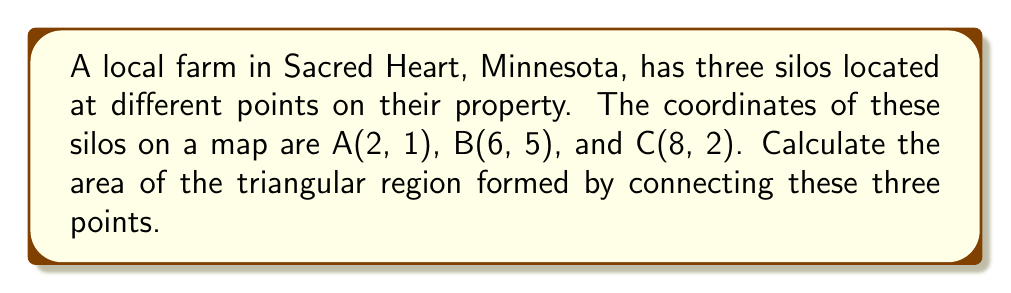Show me your answer to this math problem. To calculate the area of a triangle formed by three points on a coordinate plane, we can use the formula:

$$\text{Area} = \frac{1}{2}|x_1(y_2 - y_3) + x_2(y_3 - y_1) + x_3(y_1 - y_2)|$$

Where $(x_1, y_1)$, $(x_2, y_2)$, and $(x_3, y_3)$ are the coordinates of the three points.

Given:
- Point A: $(2, 1)$
- Point B: $(6, 5)$
- Point C: $(8, 2)$

Let's substitute these values into the formula:

$$\begin{align*}
\text{Area} &= \frac{1}{2}|2(5 - 2) + 6(2 - 1) + 8(1 - 5)| \\[6pt]
&= \frac{1}{2}|2(3) + 6(1) + 8(-4)| \\[6pt]
&= \frac{1}{2}|6 + 6 - 32| \\[6pt]
&= \frac{1}{2}|-20| \\[6pt]
&= \frac{1}{2}(20) \\[6pt]
&= 10
\end{align*}$$

Therefore, the area of the triangle formed by the three silos is 10 square units.

[asy]
unitsize(1cm);
defaultpen(fontsize(10pt));

pair A = (2,1);
pair B = (6,5);
pair C = (8,2);

draw(A--B--C--cycle, blue);

dot("A(2,1)", A, SW);
dot("B(6,5)", B, N);
dot("C(8,2)", C, SE);

xaxis(0,9,arrow=Arrow);
yaxis(0,6,arrow=Arrow);

label("x", (9,0), E);
label("y", (0,6), N);
[/asy]
Answer: 10 square units 